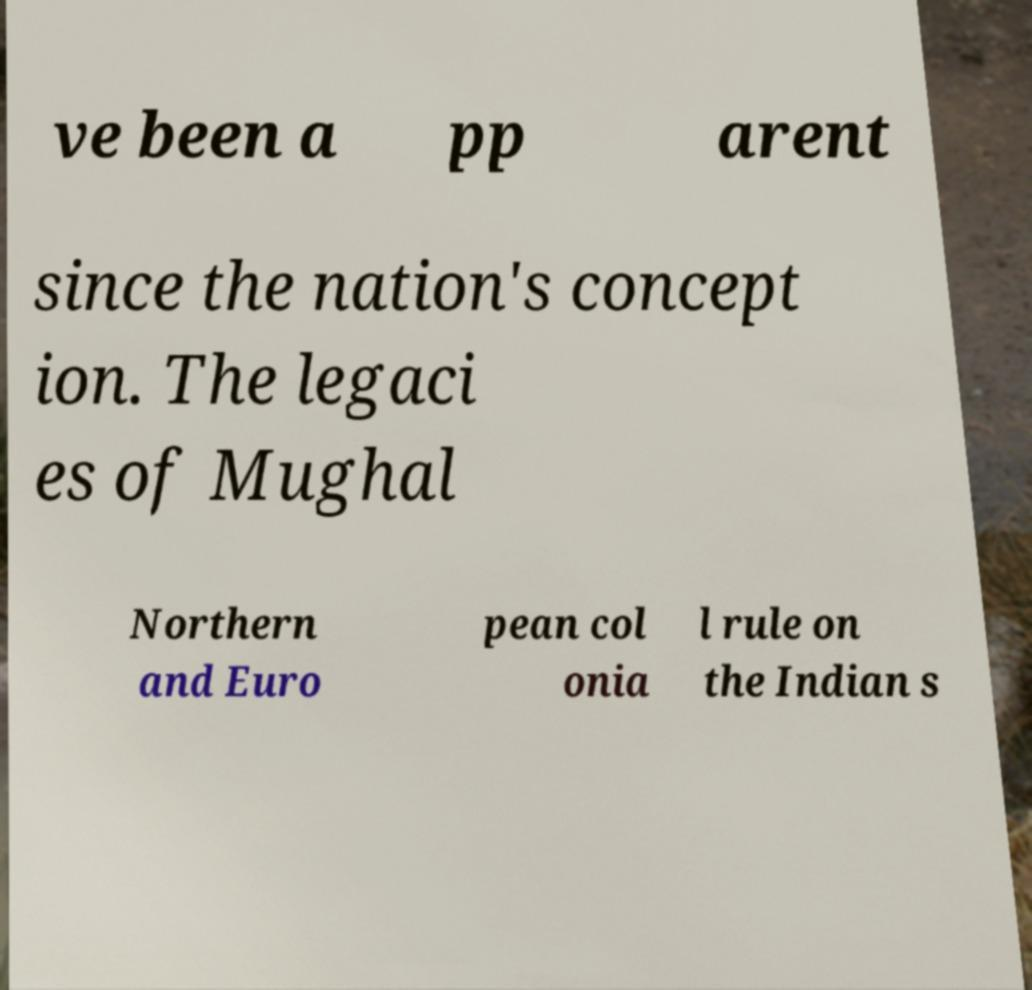Please read and relay the text visible in this image. What does it say? ve been a pp arent since the nation's concept ion. The legaci es of Mughal Northern and Euro pean col onia l rule on the Indian s 